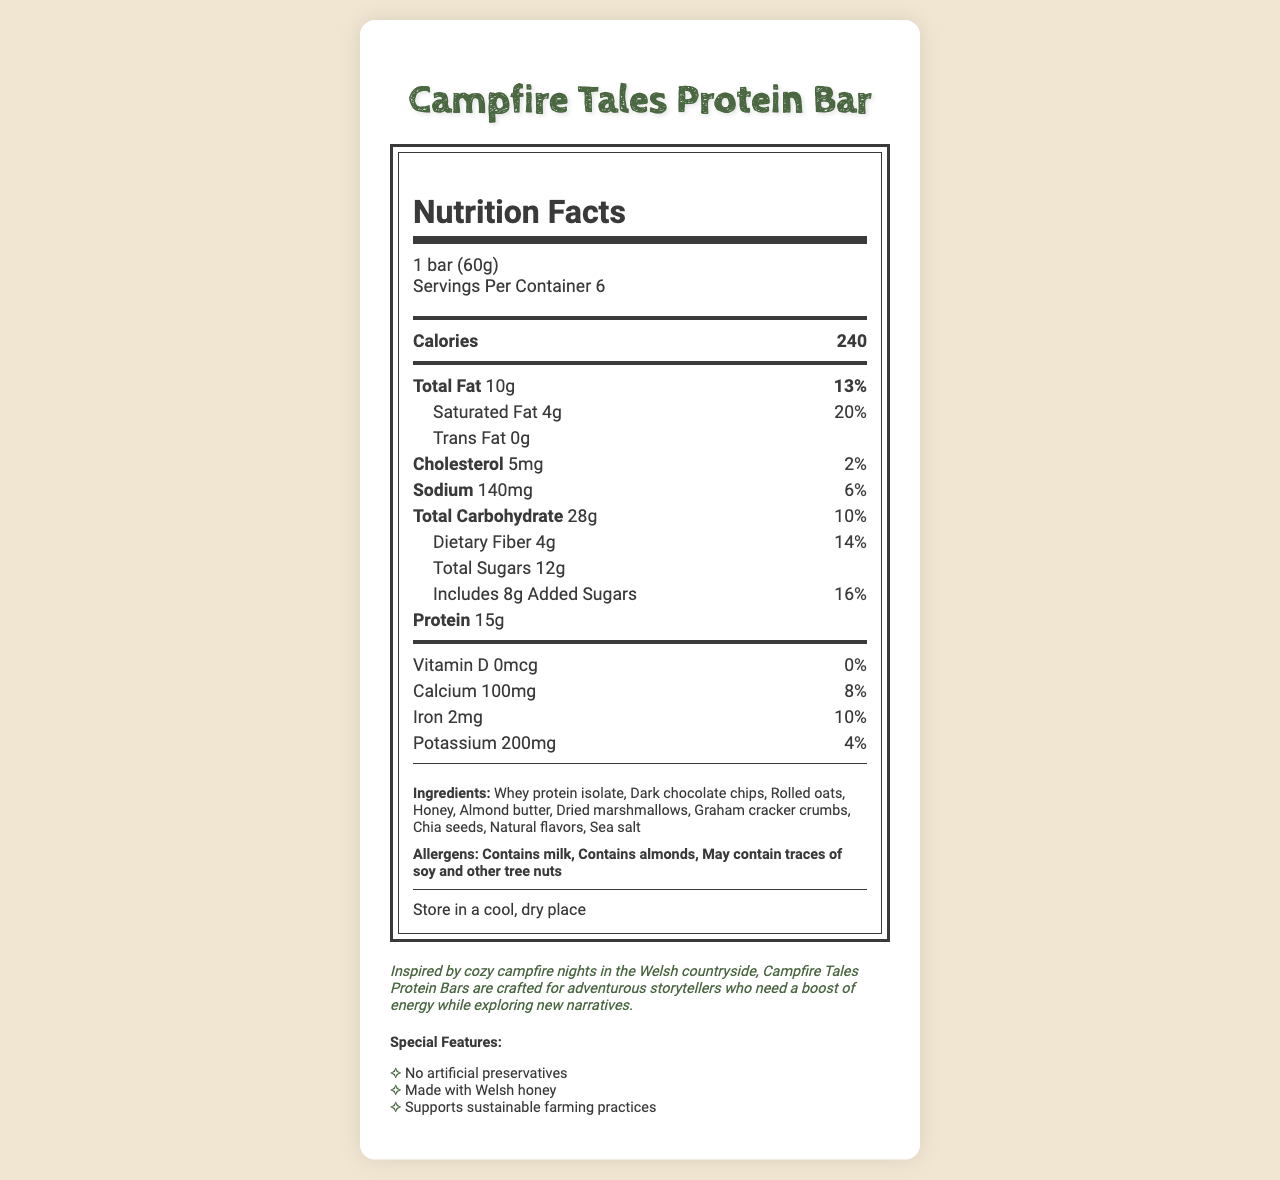what is the serving size? The serving size is mentioned at the beginning of the document under the serving info section.
Answer: 1 bar (60g) how many calories are in one serving? The number of calories per serving is listed under the calories section in bold.
Answer: 240 what is the total amount of fat per serving? The total amount of fat per serving is specified under the nutrients section.
Answer: 10g what are the two special features of the product? The special features are listed at the bottom of the document in a bulleted list.
Answer: No artificial preservatives, Made with Welsh honey how much protein does one bar contain? The protein content is listed under the nutrients section, specifically mentioned as 15g.
Answer: 15g what allergens are present in the protein bar? The allergens are listed in the allergens section of the document.
Answer: Contains milk, Contains almonds, May contain traces of soy and other tree nuts how should the product be stored? The storage instructions are given at the bottom of the ingredients and allergens section.
Answer: Store in a cool, dry place which nutrient has the highest daily value percentage in the bar? A. Total Carbohydrate B. Saturated Fat C. Dietary Fiber D. Iron Saturated fat has a daily value of 20%, which is higher than the other options listed.
Answer: B. Saturated Fat what ingredient is not included in the bar? A. Whey protein isolate B. Milk chocolate chips C. Chia seeds D. Rolled oats The ingredients list specifies dark chocolate chips, not milk chocolate chips.
Answer: B. Milk chocolate chips is the protein bar made with artificial preservatives? One of the special features mentioned is "No artificial preservatives."
Answer: No summarize the overall purpose and characteristics of the protein bar. The document describes a protein bar tailored for adventurers and storytellers, emphasizing natural ingredients, substantial nutrition, and sustainability.
Answer: The Campfire Tales Protein Bar is designed for on-the-go storytellers and inspired by campfire nights in the Welsh countryside. It provides a substantial amount of protein, is made with natural ingredients, and supports sustainable farming. The bar also avoids artificial preservatives and highlights the use of Welsh honey. does the document provide information about the origin of the graham cracker crumbs used? The document does not specify the origin of the graham cracker crumbs, only listing it as an ingredient.
Answer: Cannot be determined what is the daily value percentage of sodium per serving? The sodium content is listed under the nutrients section with a daily value of 6%.
Answer: 6% which nutrient has the lowest daily value percentage? A. Vitamin D B. Cholesterol C. Calcium D. Potassium The Vitamin D content has a daily value of 0%, which is lower than the other options provided.
Answer: A. Vitamin D 